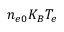<formula> <loc_0><loc_0><loc_500><loc_500>n _ { e 0 } K _ { B } T _ { e }</formula> 